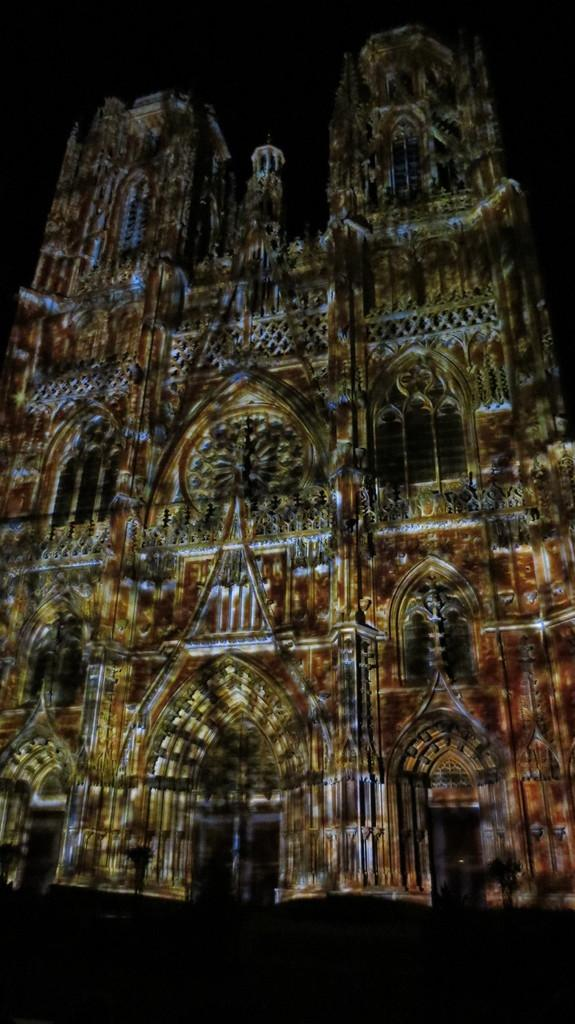What is the main subject in the image? There is a building in the image. What type of jam is being exchanged in front of the building in the image? There is no jam or exchange present in the image; it only features a building. 